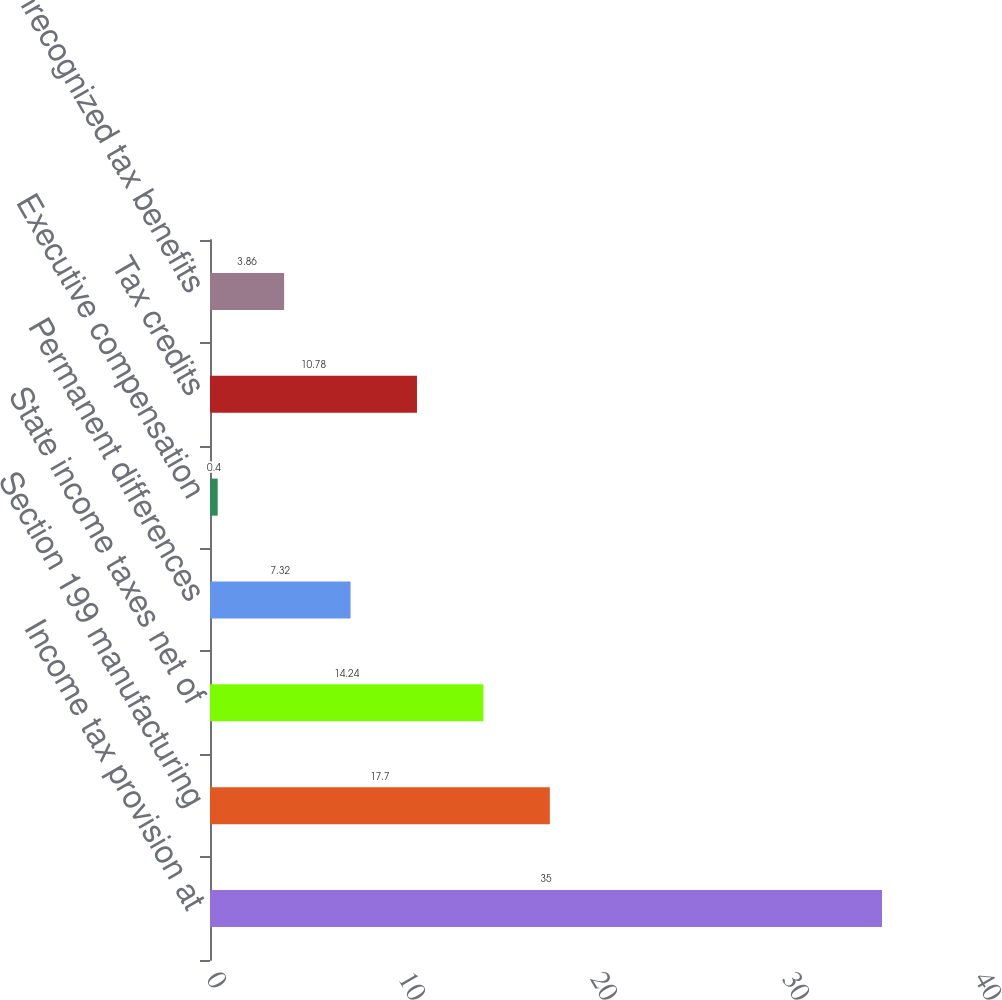Convert chart to OTSL. <chart><loc_0><loc_0><loc_500><loc_500><bar_chart><fcel>Income tax provision at<fcel>Section 199 manufacturing<fcel>State income taxes net of<fcel>Permanent differences<fcel>Executive compensation<fcel>Tax credits<fcel>Unrecognized tax benefits<nl><fcel>35<fcel>17.7<fcel>14.24<fcel>7.32<fcel>0.4<fcel>10.78<fcel>3.86<nl></chart> 